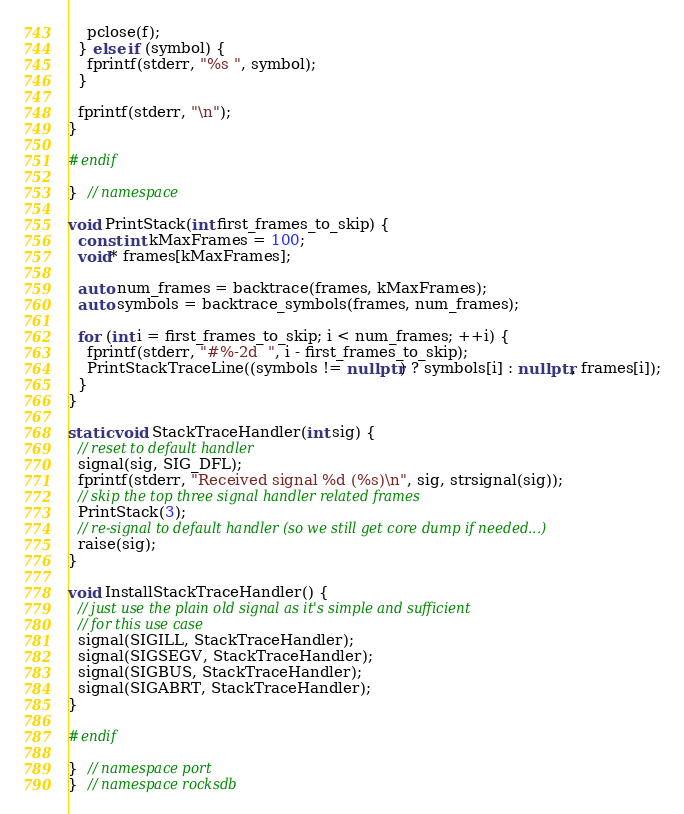Convert code to text. <code><loc_0><loc_0><loc_500><loc_500><_C++_>    pclose(f);
  } else if (symbol) {
    fprintf(stderr, "%s ", symbol);
  }

  fprintf(stderr, "\n");
}

#endif

}  // namespace

void PrintStack(int first_frames_to_skip) {
  const int kMaxFrames = 100;
  void* frames[kMaxFrames];

  auto num_frames = backtrace(frames, kMaxFrames);
  auto symbols = backtrace_symbols(frames, num_frames);

  for (int i = first_frames_to_skip; i < num_frames; ++i) {
    fprintf(stderr, "#%-2d  ", i - first_frames_to_skip);
    PrintStackTraceLine((symbols != nullptr) ? symbols[i] : nullptr, frames[i]);
  }
}

static void StackTraceHandler(int sig) {
  // reset to default handler
  signal(sig, SIG_DFL);
  fprintf(stderr, "Received signal %d (%s)\n", sig, strsignal(sig));
  // skip the top three signal handler related frames
  PrintStack(3);
  // re-signal to default handler (so we still get core dump if needed...)
  raise(sig);
}

void InstallStackTraceHandler() {
  // just use the plain old signal as it's simple and sufficient
  // for this use case
  signal(SIGILL, StackTraceHandler);
  signal(SIGSEGV, StackTraceHandler);
  signal(SIGBUS, StackTraceHandler);
  signal(SIGABRT, StackTraceHandler);
}

#endif

}  // namespace port
}  // namespace rocksdb
</code> 